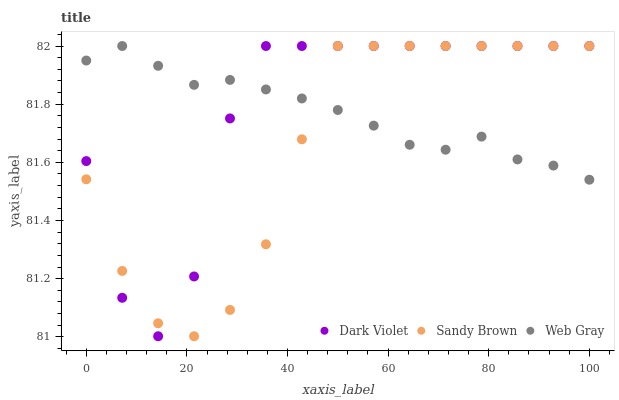Does Sandy Brown have the minimum area under the curve?
Answer yes or no. Yes. Does Dark Violet have the maximum area under the curve?
Answer yes or no. Yes. Does Dark Violet have the minimum area under the curve?
Answer yes or no. No. Does Sandy Brown have the maximum area under the curve?
Answer yes or no. No. Is Web Gray the smoothest?
Answer yes or no. Yes. Is Dark Violet the roughest?
Answer yes or no. Yes. Is Sandy Brown the smoothest?
Answer yes or no. No. Is Sandy Brown the roughest?
Answer yes or no. No. Does Sandy Brown have the lowest value?
Answer yes or no. Yes. Does Dark Violet have the lowest value?
Answer yes or no. No. Does Dark Violet have the highest value?
Answer yes or no. Yes. Does Dark Violet intersect Web Gray?
Answer yes or no. Yes. Is Dark Violet less than Web Gray?
Answer yes or no. No. Is Dark Violet greater than Web Gray?
Answer yes or no. No. 